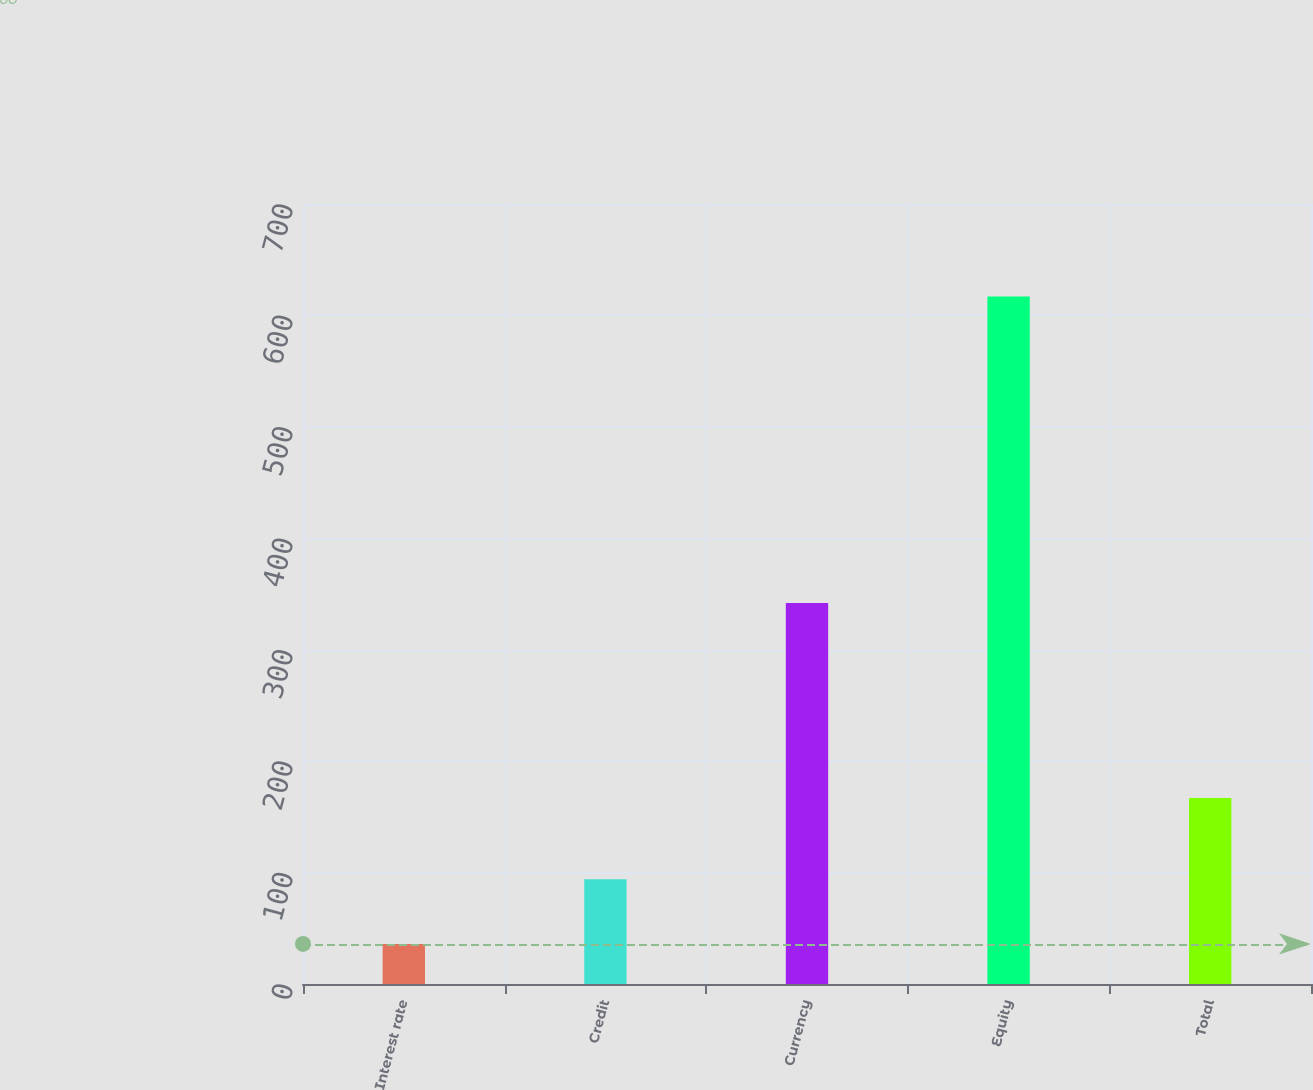Convert chart. <chart><loc_0><loc_0><loc_500><loc_500><bar_chart><fcel>Interest rate<fcel>Credit<fcel>Currency<fcel>Equity<fcel>Total<nl><fcel>36<fcel>94.1<fcel>342<fcel>617<fcel>167<nl></chart> 